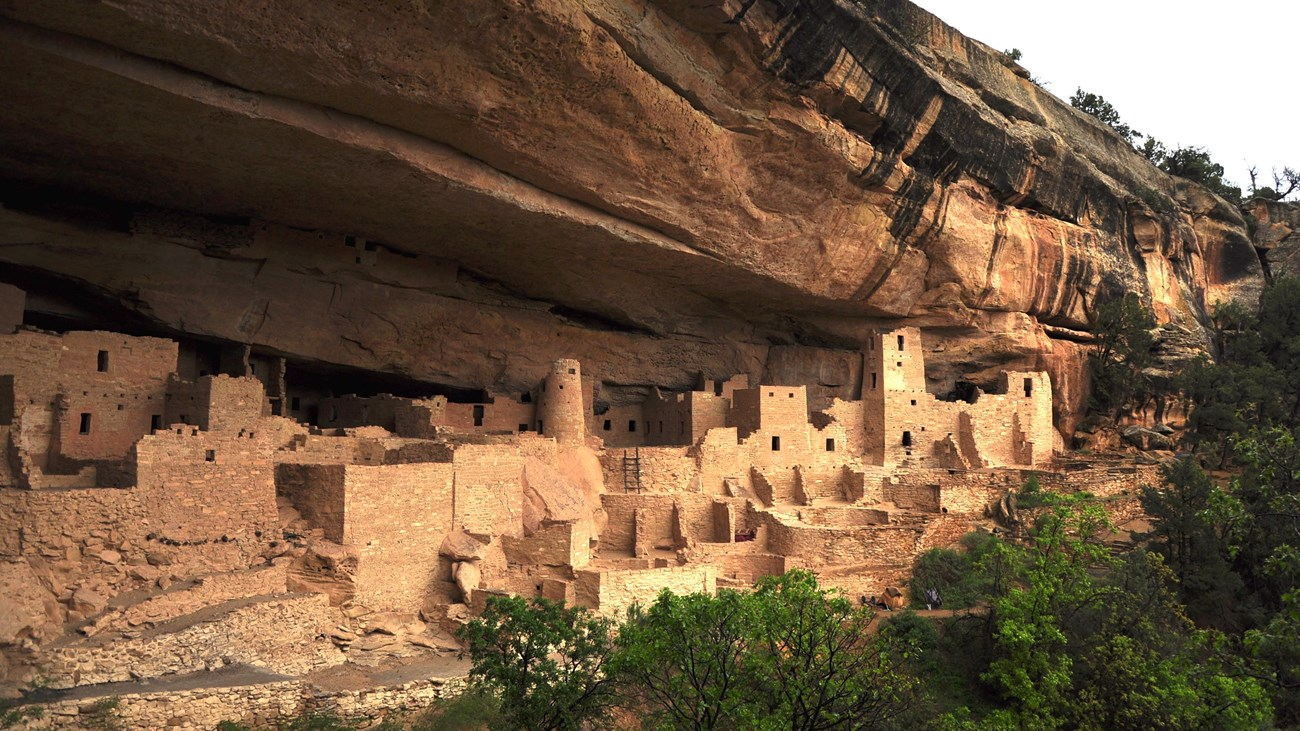Imagine you could walk through this ancient site. Describe in detail what you might see, hear, and feel. As you walk through this ancient site, you are immediately struck by the sheer scale and ingenuity of the cliff dwellings. The stone buildings rise in multiple levels, some towering above you, their windows and doorways like eyes gazing out over the vast landscape. You feel the rough texture of the stone walls, meticulously shaped by human hands centuries ago. The air is cool and slightly musty, a sharp contrast to the dry heat of the surrounding area. As you walk deeper into the dwellings, the sounds of the outside world fade, replaced by the echoes of your footsteps and the occasional drip of water from the ceiling. Imagining the bustle of ancient life, you can almost hear the faint whispers of voices, the grinding of corn, and the laughter of children. Each room tells a story, with remnants of pottery, grinding stones, and even soot-stained ceilings from ancient hearths. The connection to a long-gone civilization is palpable, leaving you in awe of their resilience and ingenuity. 